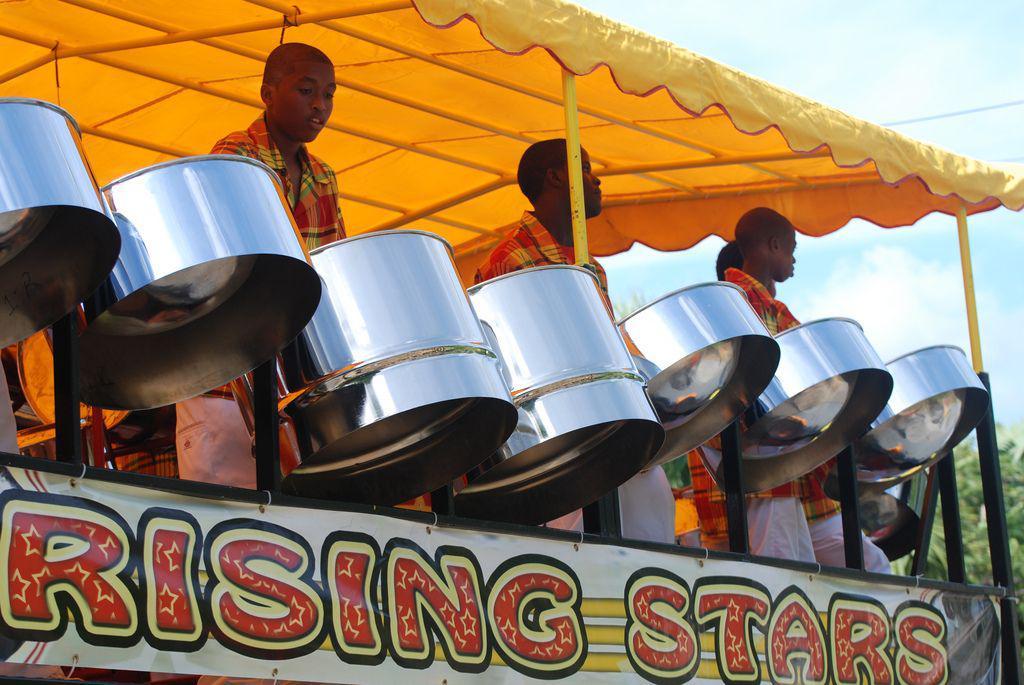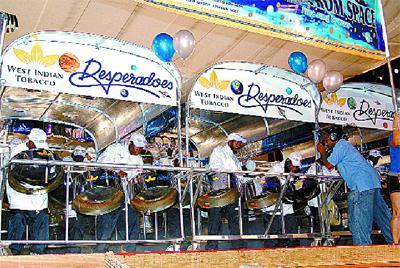The first image is the image on the left, the second image is the image on the right. Analyze the images presented: Is the assertion "The foreground of one image features a row of at least three forward-turned people in red shirts bending over silver drums." valid? Answer yes or no. No. The first image is the image on the left, the second image is the image on the right. Analyze the images presented: Is the assertion "In the image to the right, people wearing white shirts are banging steel drum instruments." valid? Answer yes or no. Yes. 